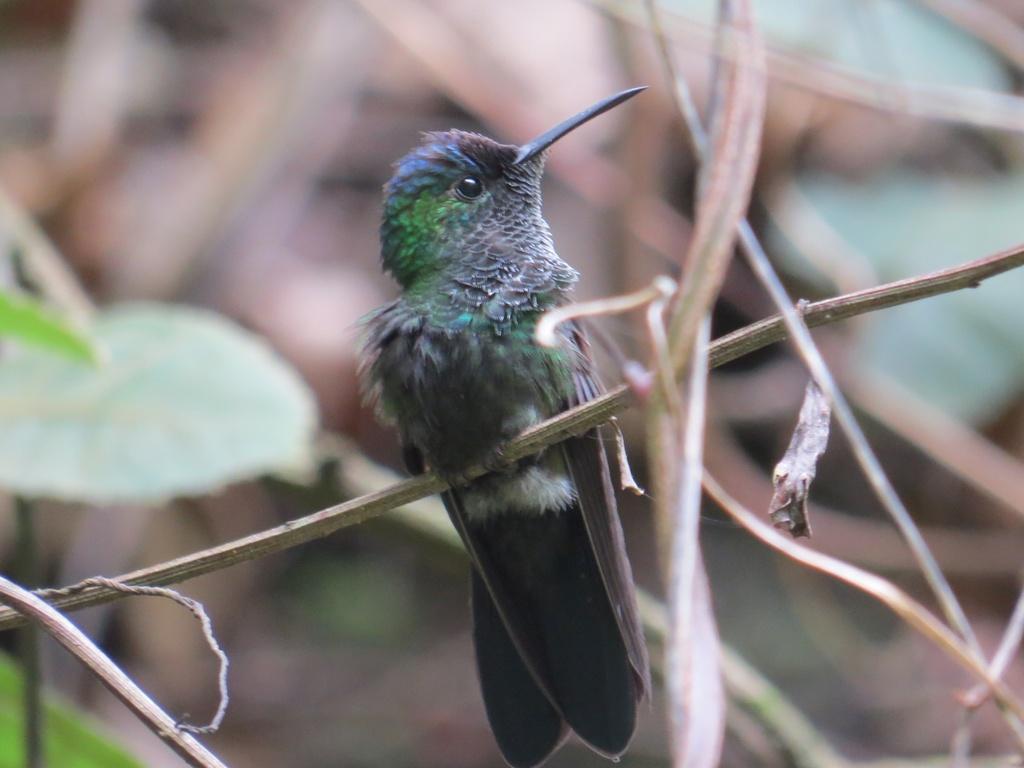Please provide a concise description of this image. As we can see in the image in the middle there is a black color bird and on the left side there is leaf. 